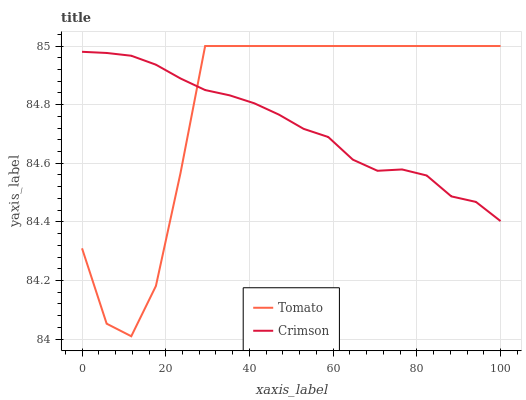Does Crimson have the minimum area under the curve?
Answer yes or no. Yes. Does Tomato have the maximum area under the curve?
Answer yes or no. Yes. Does Crimson have the maximum area under the curve?
Answer yes or no. No. Is Crimson the smoothest?
Answer yes or no. Yes. Is Tomato the roughest?
Answer yes or no. Yes. Is Crimson the roughest?
Answer yes or no. No. Does Tomato have the lowest value?
Answer yes or no. Yes. Does Crimson have the lowest value?
Answer yes or no. No. Does Tomato have the highest value?
Answer yes or no. Yes. Does Crimson have the highest value?
Answer yes or no. No. Does Tomato intersect Crimson?
Answer yes or no. Yes. Is Tomato less than Crimson?
Answer yes or no. No. Is Tomato greater than Crimson?
Answer yes or no. No. 